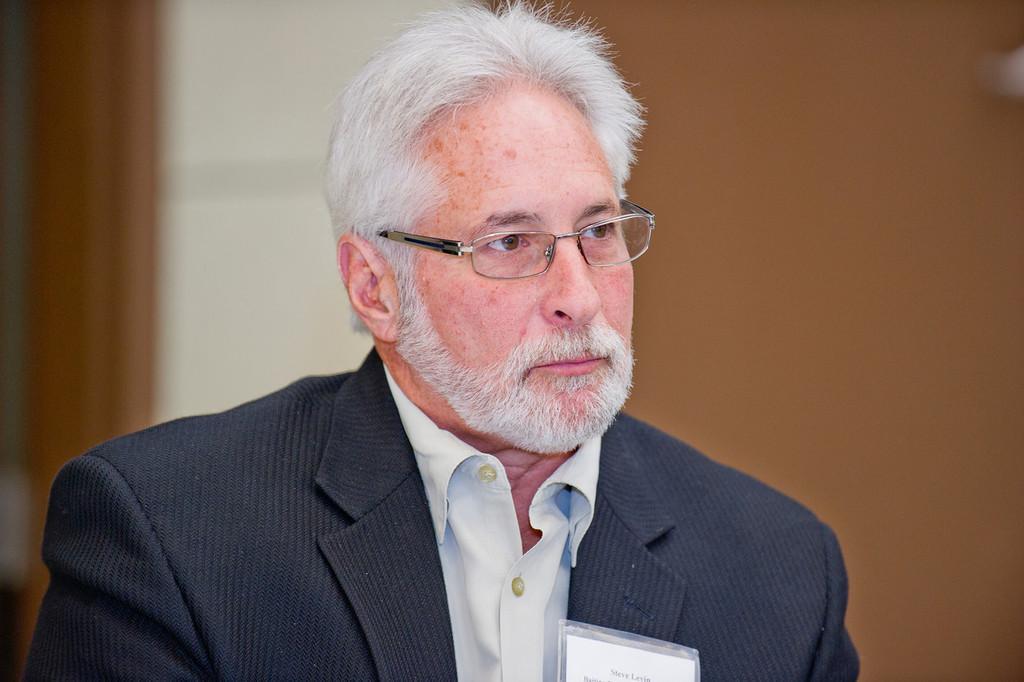Describe this image in one or two sentences. Here we can see a man. He is in a suit and he has spectacles. There is a blur background. 